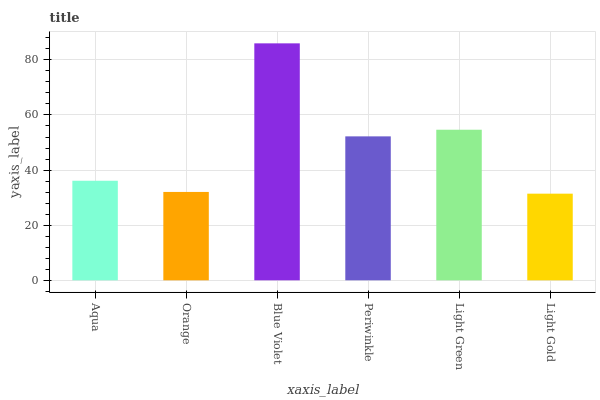Is Orange the minimum?
Answer yes or no. No. Is Orange the maximum?
Answer yes or no. No. Is Aqua greater than Orange?
Answer yes or no. Yes. Is Orange less than Aqua?
Answer yes or no. Yes. Is Orange greater than Aqua?
Answer yes or no. No. Is Aqua less than Orange?
Answer yes or no. No. Is Periwinkle the high median?
Answer yes or no. Yes. Is Aqua the low median?
Answer yes or no. Yes. Is Orange the high median?
Answer yes or no. No. Is Light Gold the low median?
Answer yes or no. No. 